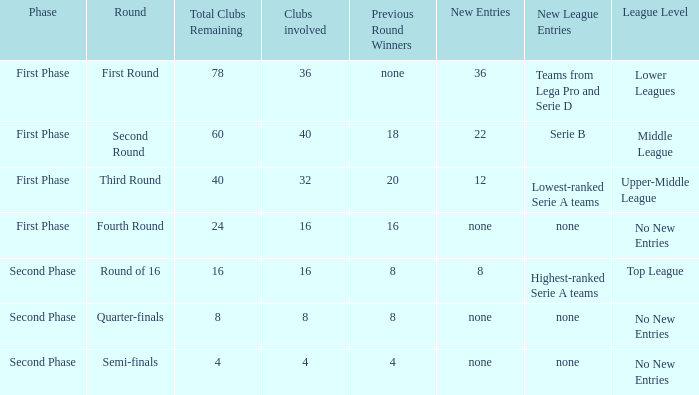The latest additions this cycle were displayed as 12, in which stage would you locate this? First Phase. 